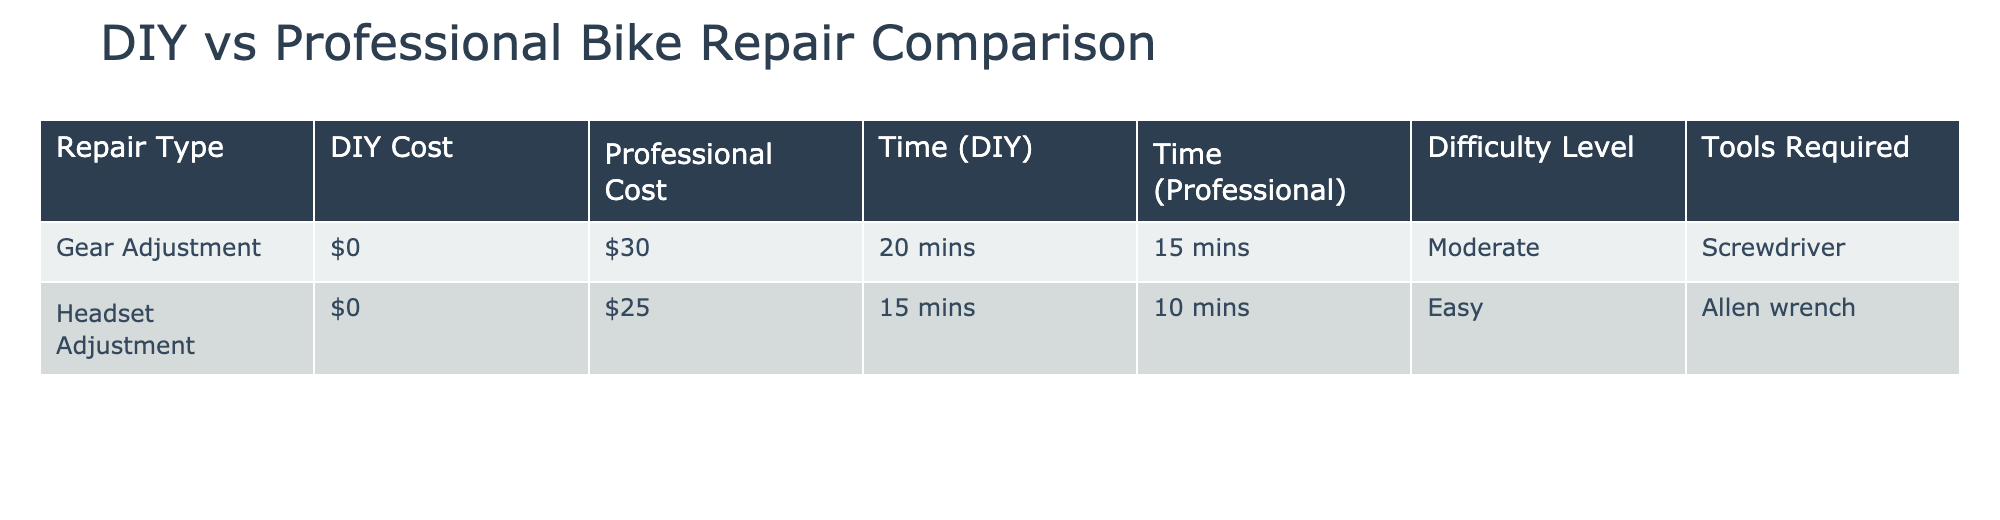What is the DIY cost for gear adjustment? The table specifies the DIY cost for gear adjustment in the DIY Cost column, which shows a value of $0.
Answer: $0 What is the professional cost for headset adjustment? By examining the Professional Cost column for headset adjustment, we find the value is $25.
Answer: $25 Is the time required for DIY gear adjustment less than the time required for professional servicing? The table shows that DIY gear adjustment takes 20 minutes and professional servicing takes 15 minutes. Since 20 minutes is greater than 15 minutes, the statement is false.
Answer: No What tools are required for professional servicing of headset adjustment? The Tools Required column indicates that an Allen wrench is necessary for professional servicing of the headset adjustment.
Answer: Allen wrench What is the average professional cost for both repair types? We find the professional costs are $30 for gear adjustment and $25 for headset adjustment. Summing these gives $30 + $25 = $55. Dividing by the number of repair types (2), the average is $55 / 2 = $27.50.
Answer: $27.50 Which repair type has a higher difficulty level: gear adjustment or headset adjustment? The Difficulty Level column shows that the gear adjustment has a 'Moderate' level, while the headset adjustment has an 'Easy' level. Since 'Moderate' is more difficult than 'Easy', gear adjustment is the higher difficulty.
Answer: Gear adjustment How much longer is the professional servicing time for gear adjustment compared to DIY? The DIY time for gear adjustment is 20 minutes while the professional time is 15 minutes. To find the difference, we calculate 20 mins - 15 mins = 5 mins. Thus, professional servicing is shorter by 5 minutes.
Answer: 5 minutes Are the DIY costs the same for both repairs? The DIY Cost column shows $0 for both repairs, indicating that the costs are identical. Therefore, the answer is true.
Answer: Yes What is the total DIY time for completing both repairs? The table states that the DIY time for gear adjustment is 20 minutes and for headset adjustment is 15 minutes. Adding these, we find 20 mins + 15 mins = 35 mins, which represents the total DIY time.
Answer: 35 minutes 